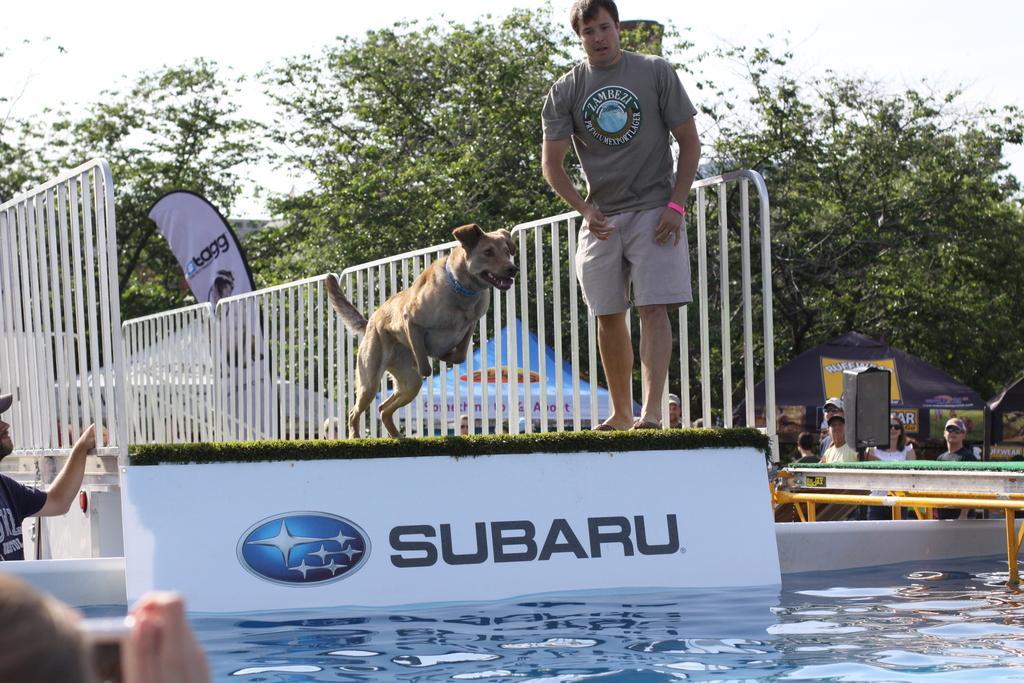Please provide a concise description of this image. In this image there is a dog about to jump in the water, beside the dog there is a person standing, besides the dog there is a metal grill fence, beside the grill fence there is a person standing, in front of him there is another person clicking a picture, beside the metal grill fence there are a few other people standing, behind them there are tents and trees. 